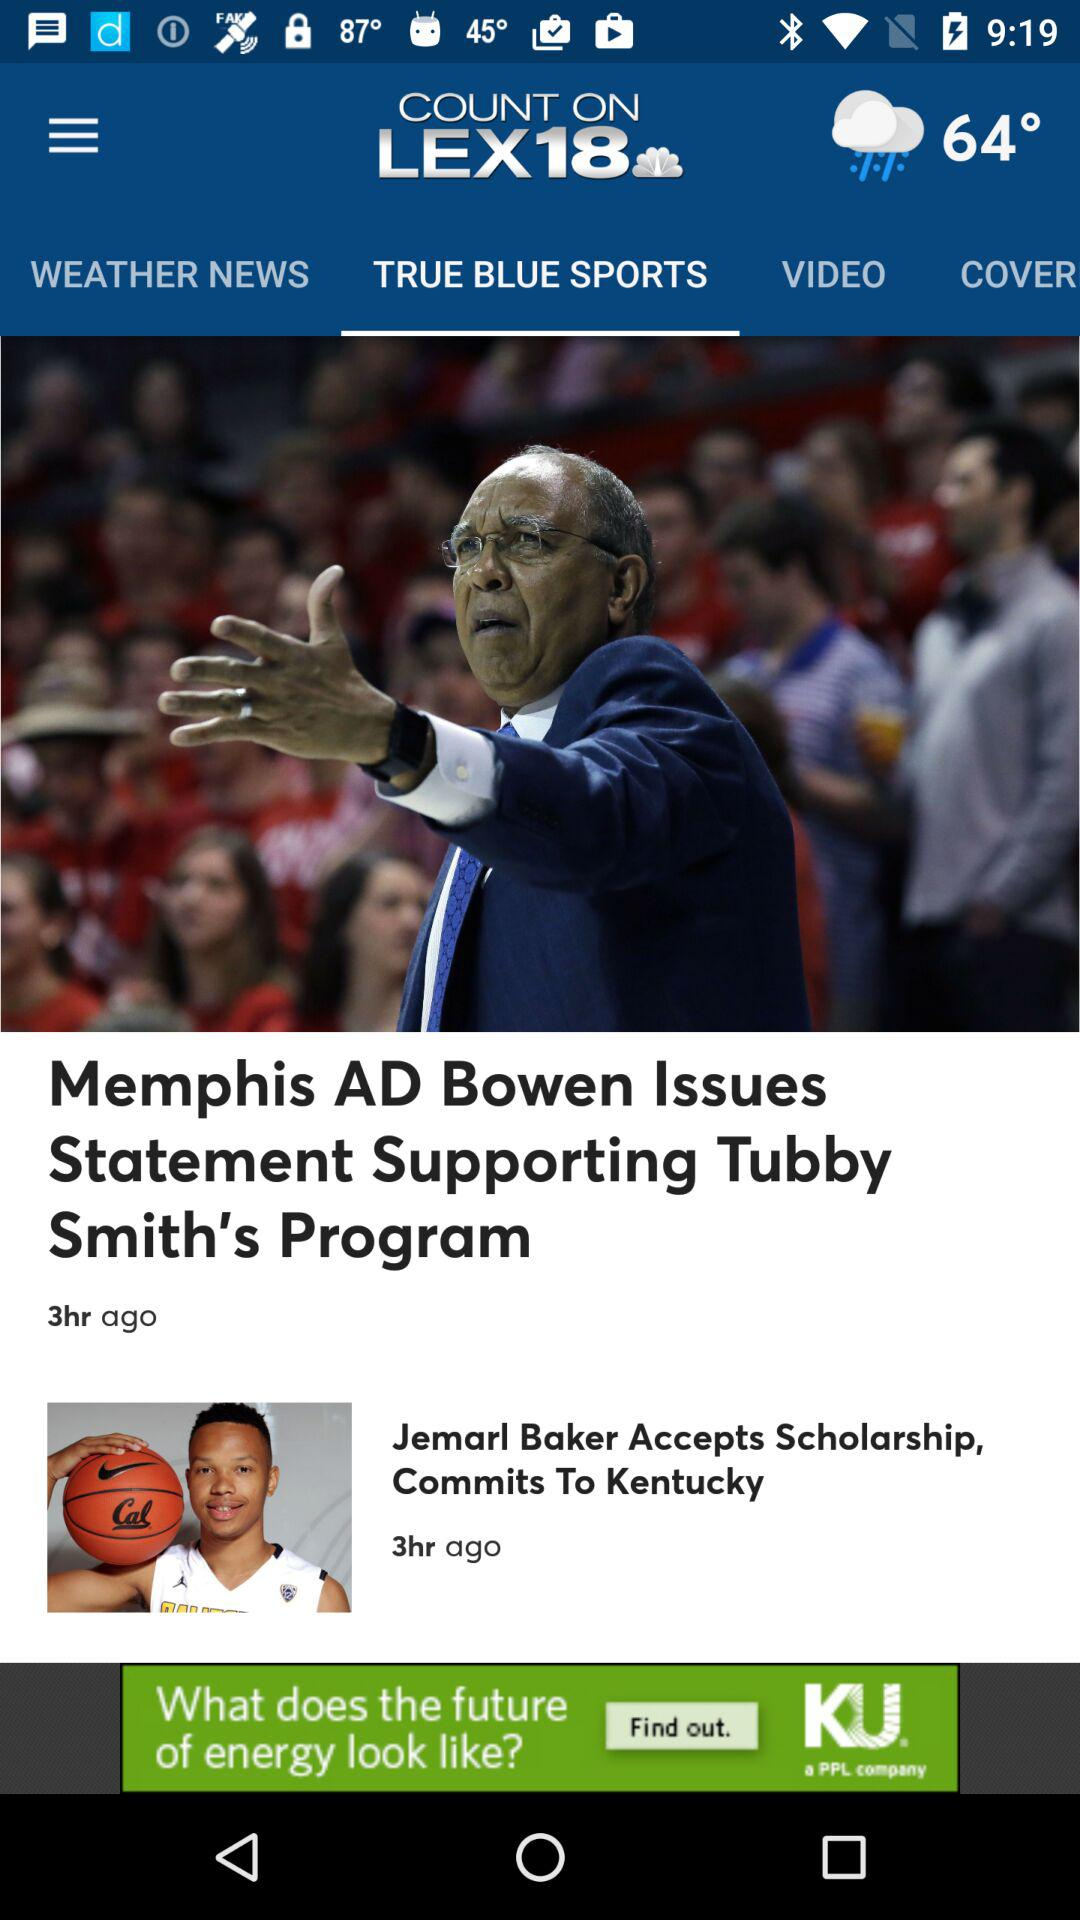What is the selected tab? The selected tab is "TRUE BLUE SPORTS". 